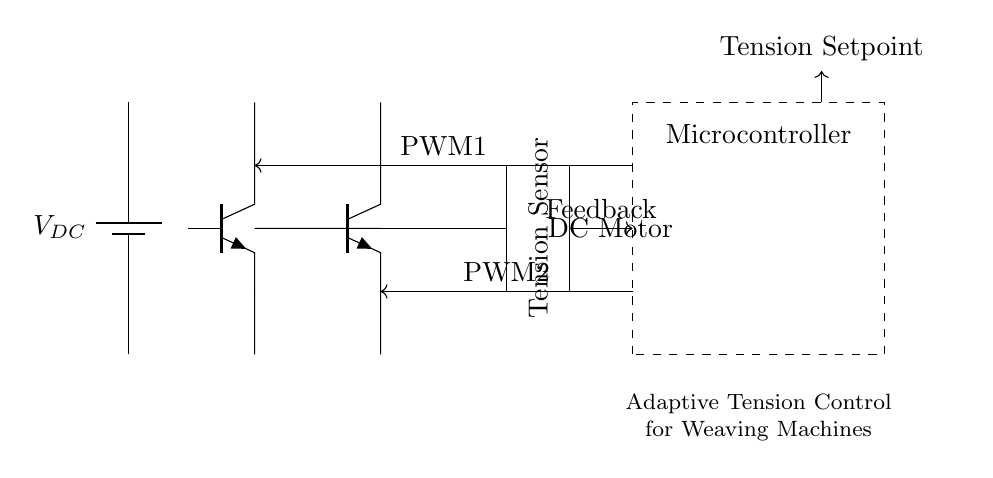What is the main component responsible for controlling motor speed in this circuit? The microcontroller sends PWM signals to the H-bridge, adjusting the motor speed by controlling the power delivered to the motor.
Answer: microcontroller How many transistors are used in this H-bridge configuration? The H-bridge consists of four transistors (two on each side), enabling bidirectional control of the motor.
Answer: four What type of motor is depicted in this circuit? The diagram specifically indicates the use of a DC motor for operation within the system.
Answer: DC motor What is the role of the tension sensor in this circuit? The tension sensor provides real-time feedback to the microcontroller, allowing it to adjust tension dynamically according to the weaving process requirements.
Answer: feedback What signal does the microcontroller output to control the motor? The microcontroller outputs PWM signals, which modulate the power supplied to the motor through the H-bridge for effective speed control.
Answer: PWM signals 